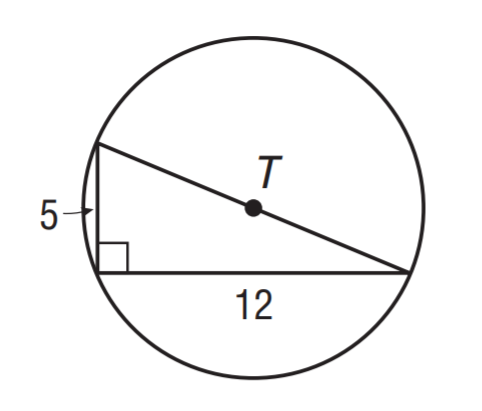Question: What is the circumference of \odot T? Round to the nearest tenth.
Choices:
A. 37.2
B. 39.6
C. 40.8
D. 42.4
Answer with the letter. Answer: C 